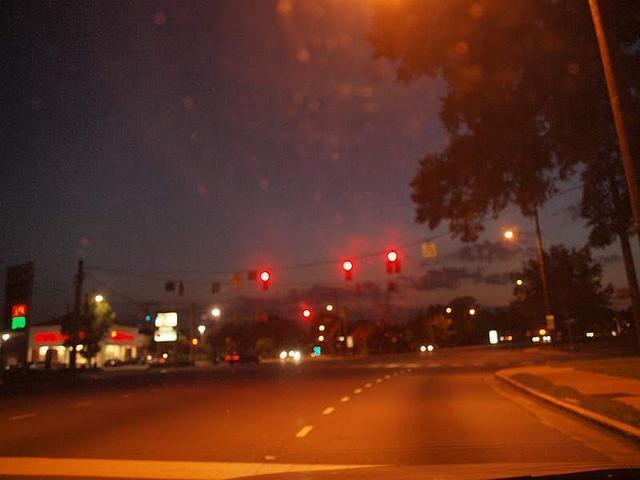How many red traffic lights are visible?
Give a very brief answer. 4. How many bears are there?
Give a very brief answer. 0. 